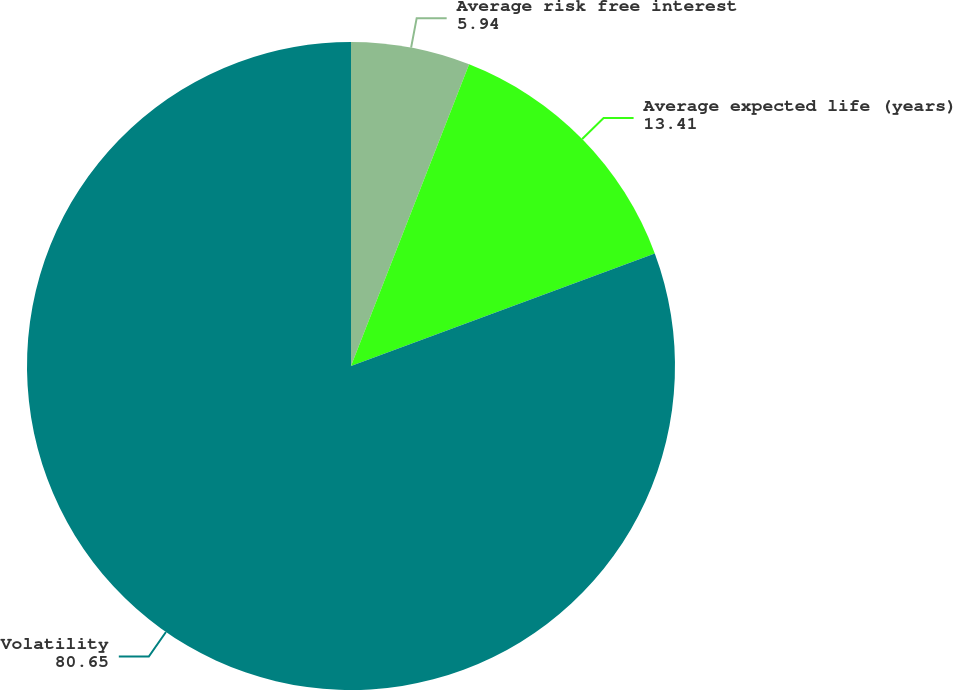Convert chart. <chart><loc_0><loc_0><loc_500><loc_500><pie_chart><fcel>Average risk free interest<fcel>Average expected life (years)<fcel>Volatility<nl><fcel>5.94%<fcel>13.41%<fcel>80.65%<nl></chart> 